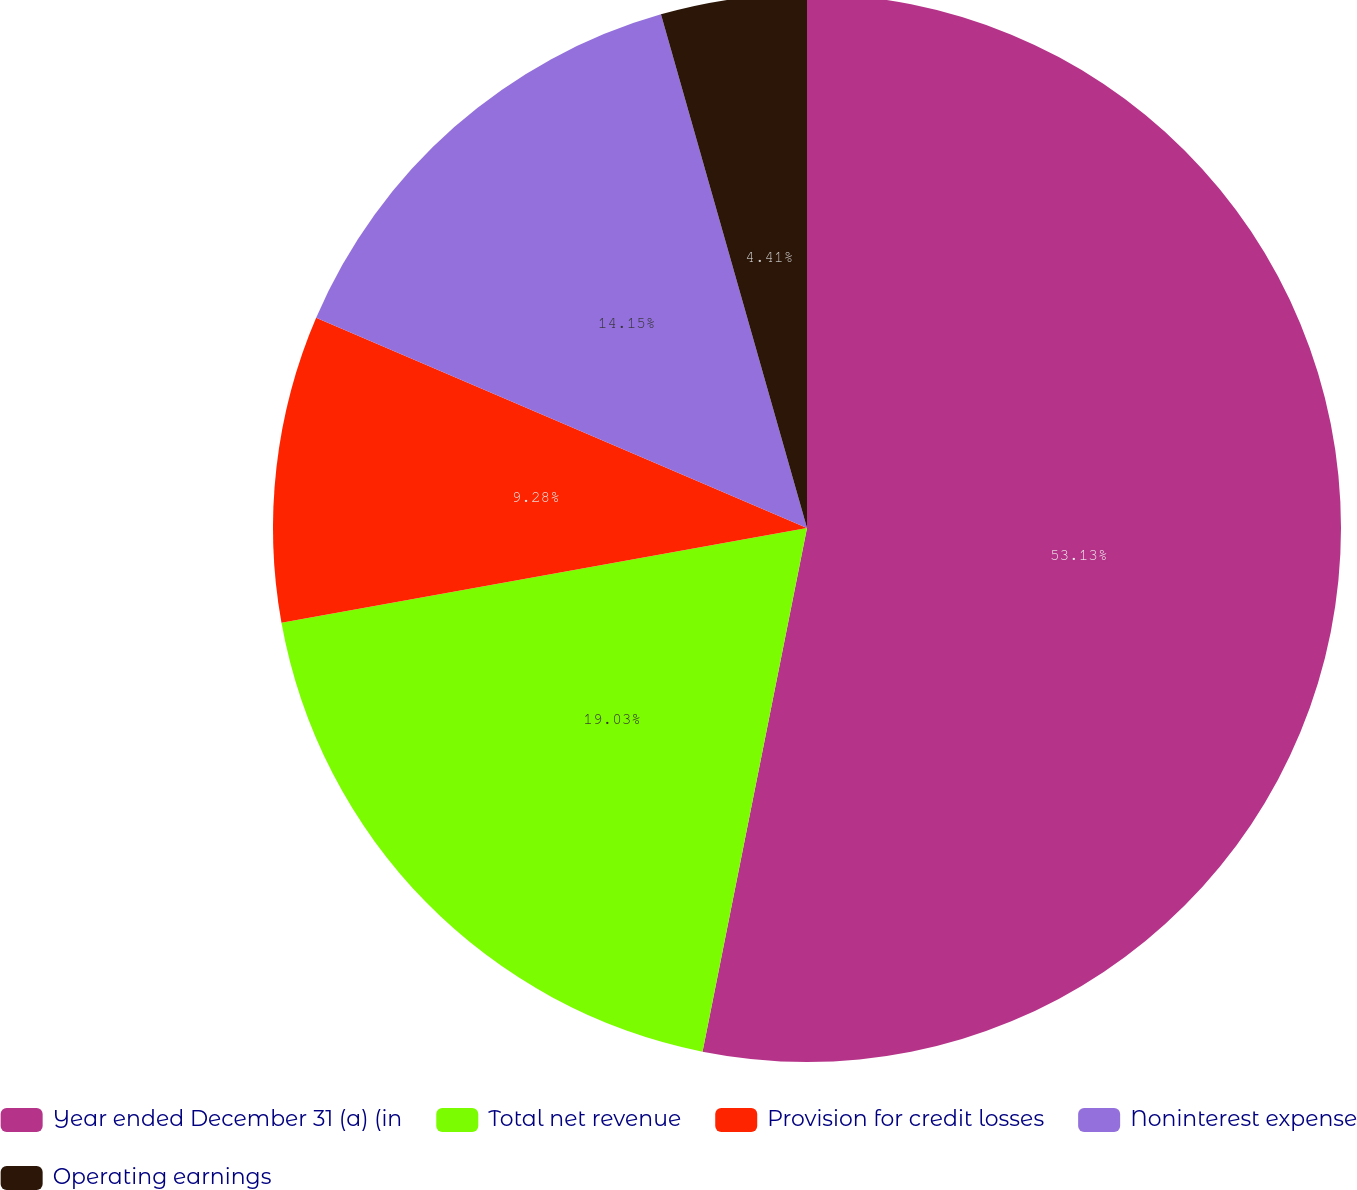Convert chart to OTSL. <chart><loc_0><loc_0><loc_500><loc_500><pie_chart><fcel>Year ended December 31 (a) (in<fcel>Total net revenue<fcel>Provision for credit losses<fcel>Noninterest expense<fcel>Operating earnings<nl><fcel>53.14%<fcel>19.03%<fcel>9.28%<fcel>14.15%<fcel>4.41%<nl></chart> 